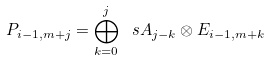Convert formula to latex. <formula><loc_0><loc_0><loc_500><loc_500>P _ { i - 1 , m + j } = \bigoplus _ { k = 0 } ^ { j } \ s A _ { j - k } \otimes E _ { i - 1 , m + k }</formula> 